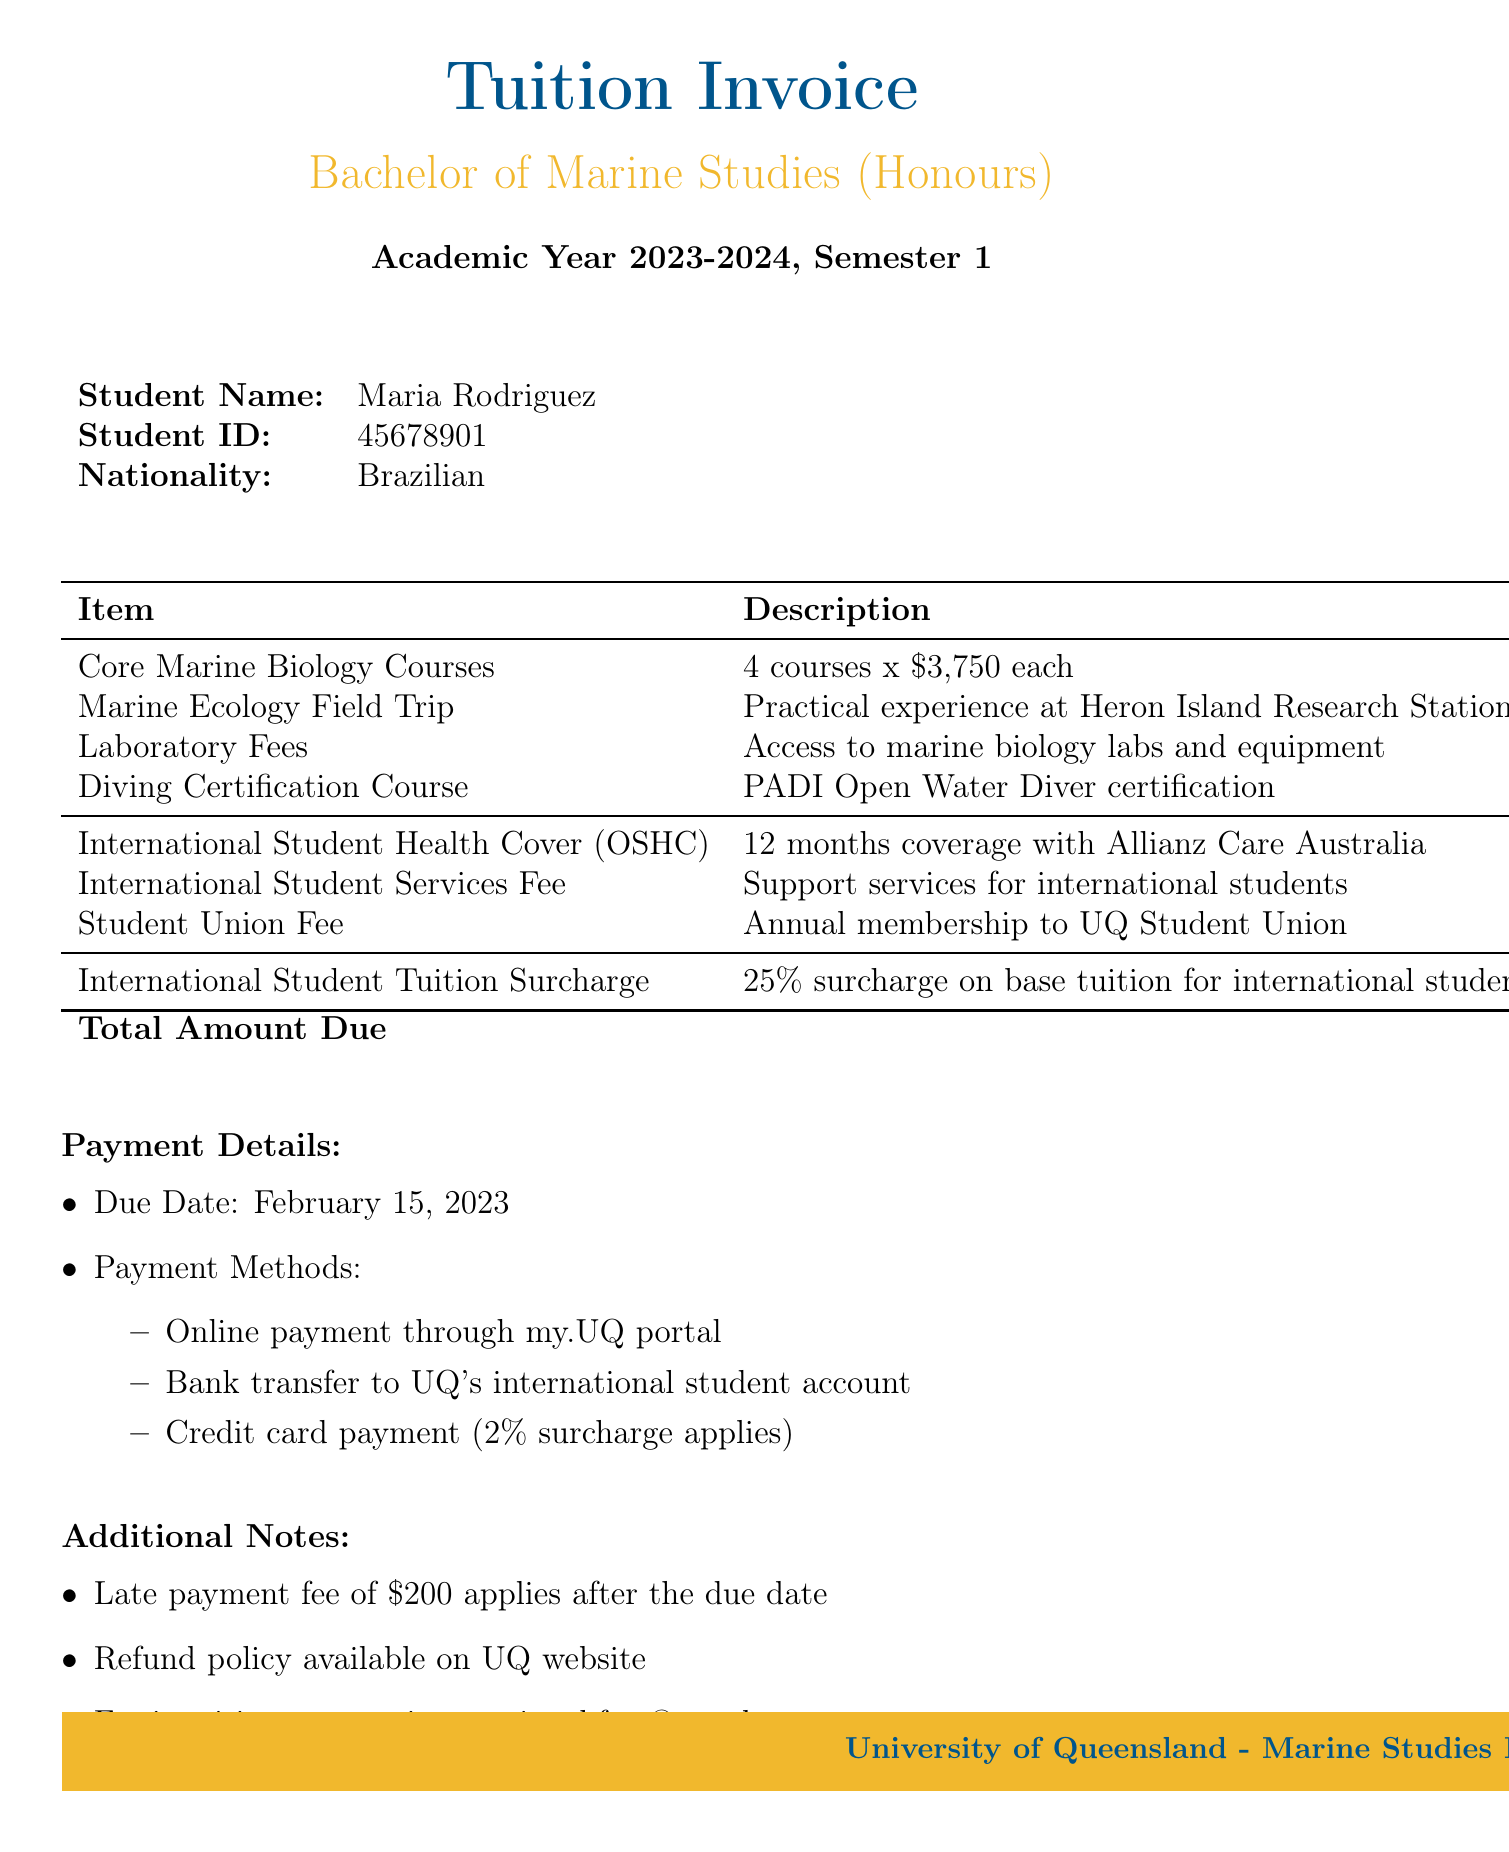What is the university name? The university name is stated prominently at the top of the document.
Answer: University of Queensland What is the program name? The program name is listed below the invoice title in the document.
Answer: Bachelor of Marine Studies (Honours) What is the total amount due? The total amount due is highlighted in the invoice summary, calculated from the breakdown of fees.
Answer: 24,350.00 What is the due date for payment? The due date is mentioned explicitly in the payment details section of the document.
Answer: February 15, 2023 What percentage surcharge do international students pay? The surcharge percentage is specified in the surcharges section of the invoice.
Answer: 25% What is included in the International Student Health Cover? This item provides coverage details for health insurance in the document.
Answer: 12 months coverage with Allianz Care Australia How many core marine biology courses are there? The number of core courses is mentioned in the tuition breakdown section.
Answer: 4 courses What is the laboratory fee amount? The laboratory fee is listed under the tuition breakdown with its corresponding amount.
Answer: 1,200.00 What methods of payment are accepted? Various methods of payment are outlined in the payment details section of the document.
Answer: Online payment, bank transfer, credit card payment 